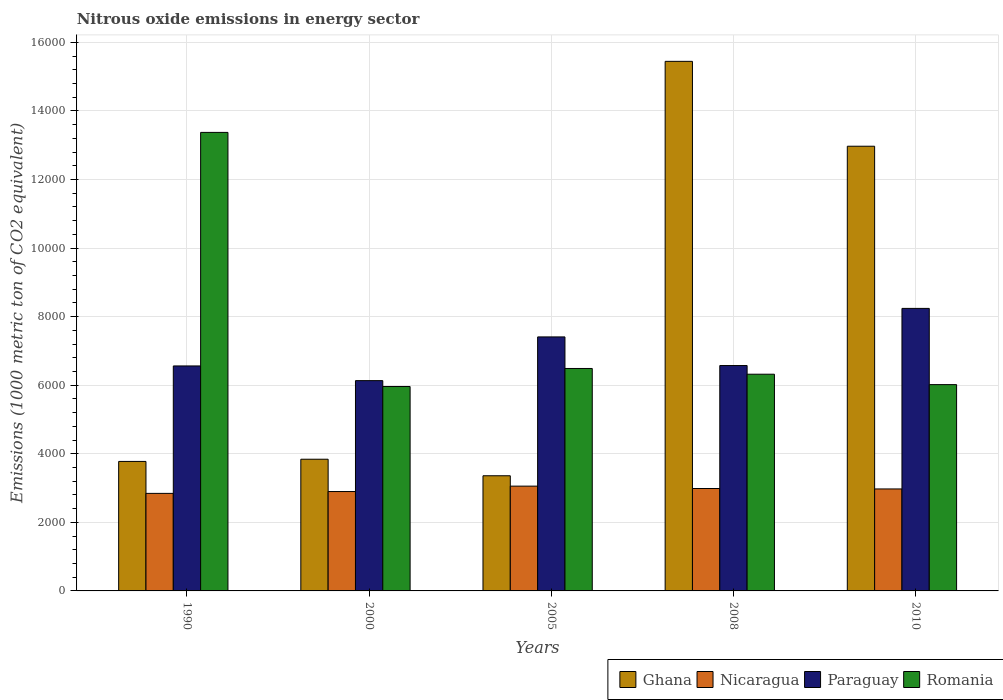How many different coloured bars are there?
Your answer should be very brief. 4. Are the number of bars per tick equal to the number of legend labels?
Your answer should be compact. Yes. Are the number of bars on each tick of the X-axis equal?
Make the answer very short. Yes. How many bars are there on the 1st tick from the left?
Make the answer very short. 4. In how many cases, is the number of bars for a given year not equal to the number of legend labels?
Offer a terse response. 0. What is the amount of nitrous oxide emitted in Nicaragua in 2010?
Give a very brief answer. 2973.9. Across all years, what is the maximum amount of nitrous oxide emitted in Paraguay?
Keep it short and to the point. 8239.6. Across all years, what is the minimum amount of nitrous oxide emitted in Romania?
Provide a succinct answer. 5961.2. In which year was the amount of nitrous oxide emitted in Paraguay maximum?
Keep it short and to the point. 2010. In which year was the amount of nitrous oxide emitted in Paraguay minimum?
Your response must be concise. 2000. What is the total amount of nitrous oxide emitted in Ghana in the graph?
Offer a terse response. 3.94e+04. What is the difference between the amount of nitrous oxide emitted in Romania in 1990 and that in 2010?
Your answer should be compact. 7355.9. What is the difference between the amount of nitrous oxide emitted in Ghana in 2005 and the amount of nitrous oxide emitted in Paraguay in 1990?
Make the answer very short. -3202.5. What is the average amount of nitrous oxide emitted in Ghana per year?
Your answer should be very brief. 7877.78. In the year 2000, what is the difference between the amount of nitrous oxide emitted in Nicaragua and amount of nitrous oxide emitted in Ghana?
Provide a succinct answer. -942.6. What is the ratio of the amount of nitrous oxide emitted in Nicaragua in 1990 to that in 2010?
Offer a very short reply. 0.96. Is the difference between the amount of nitrous oxide emitted in Nicaragua in 1990 and 2005 greater than the difference between the amount of nitrous oxide emitted in Ghana in 1990 and 2005?
Keep it short and to the point. No. What is the difference between the highest and the second highest amount of nitrous oxide emitted in Ghana?
Your response must be concise. 2475.2. What is the difference between the highest and the lowest amount of nitrous oxide emitted in Romania?
Offer a very short reply. 7411.1. In how many years, is the amount of nitrous oxide emitted in Paraguay greater than the average amount of nitrous oxide emitted in Paraguay taken over all years?
Offer a very short reply. 2. Is it the case that in every year, the sum of the amount of nitrous oxide emitted in Romania and amount of nitrous oxide emitted in Paraguay is greater than the sum of amount of nitrous oxide emitted in Nicaragua and amount of nitrous oxide emitted in Ghana?
Keep it short and to the point. Yes. What does the 3rd bar from the left in 2008 represents?
Ensure brevity in your answer.  Paraguay. What does the 2nd bar from the right in 2005 represents?
Offer a terse response. Paraguay. Is it the case that in every year, the sum of the amount of nitrous oxide emitted in Paraguay and amount of nitrous oxide emitted in Nicaragua is greater than the amount of nitrous oxide emitted in Romania?
Make the answer very short. No. How many bars are there?
Your answer should be compact. 20. Are all the bars in the graph horizontal?
Provide a short and direct response. No. Are the values on the major ticks of Y-axis written in scientific E-notation?
Give a very brief answer. No. Does the graph contain any zero values?
Ensure brevity in your answer.  No. Where does the legend appear in the graph?
Your answer should be very brief. Bottom right. What is the title of the graph?
Your answer should be compact. Nitrous oxide emissions in energy sector. What is the label or title of the Y-axis?
Your answer should be compact. Emissions (1000 metric ton of CO2 equivalent). What is the Emissions (1000 metric ton of CO2 equivalent) of Ghana in 1990?
Offer a terse response. 3776.4. What is the Emissions (1000 metric ton of CO2 equivalent) in Nicaragua in 1990?
Provide a short and direct response. 2844.7. What is the Emissions (1000 metric ton of CO2 equivalent) of Paraguay in 1990?
Offer a very short reply. 6561.2. What is the Emissions (1000 metric ton of CO2 equivalent) in Romania in 1990?
Give a very brief answer. 1.34e+04. What is the Emissions (1000 metric ton of CO2 equivalent) in Ghana in 2000?
Provide a short and direct response. 3840.8. What is the Emissions (1000 metric ton of CO2 equivalent) of Nicaragua in 2000?
Make the answer very short. 2898.2. What is the Emissions (1000 metric ton of CO2 equivalent) in Paraguay in 2000?
Your response must be concise. 6132.8. What is the Emissions (1000 metric ton of CO2 equivalent) of Romania in 2000?
Offer a very short reply. 5961.2. What is the Emissions (1000 metric ton of CO2 equivalent) of Ghana in 2005?
Make the answer very short. 3358.7. What is the Emissions (1000 metric ton of CO2 equivalent) of Nicaragua in 2005?
Your answer should be compact. 3056.1. What is the Emissions (1000 metric ton of CO2 equivalent) of Paraguay in 2005?
Provide a short and direct response. 7407.7. What is the Emissions (1000 metric ton of CO2 equivalent) of Romania in 2005?
Ensure brevity in your answer.  6487.3. What is the Emissions (1000 metric ton of CO2 equivalent) of Ghana in 2008?
Give a very brief answer. 1.54e+04. What is the Emissions (1000 metric ton of CO2 equivalent) in Nicaragua in 2008?
Keep it short and to the point. 2986.9. What is the Emissions (1000 metric ton of CO2 equivalent) of Paraguay in 2008?
Give a very brief answer. 6573. What is the Emissions (1000 metric ton of CO2 equivalent) in Romania in 2008?
Your answer should be very brief. 6320.1. What is the Emissions (1000 metric ton of CO2 equivalent) of Ghana in 2010?
Your answer should be compact. 1.30e+04. What is the Emissions (1000 metric ton of CO2 equivalent) in Nicaragua in 2010?
Offer a terse response. 2973.9. What is the Emissions (1000 metric ton of CO2 equivalent) of Paraguay in 2010?
Keep it short and to the point. 8239.6. What is the Emissions (1000 metric ton of CO2 equivalent) in Romania in 2010?
Give a very brief answer. 6016.4. Across all years, what is the maximum Emissions (1000 metric ton of CO2 equivalent) of Ghana?
Give a very brief answer. 1.54e+04. Across all years, what is the maximum Emissions (1000 metric ton of CO2 equivalent) in Nicaragua?
Offer a terse response. 3056.1. Across all years, what is the maximum Emissions (1000 metric ton of CO2 equivalent) of Paraguay?
Make the answer very short. 8239.6. Across all years, what is the maximum Emissions (1000 metric ton of CO2 equivalent) in Romania?
Keep it short and to the point. 1.34e+04. Across all years, what is the minimum Emissions (1000 metric ton of CO2 equivalent) in Ghana?
Give a very brief answer. 3358.7. Across all years, what is the minimum Emissions (1000 metric ton of CO2 equivalent) of Nicaragua?
Offer a terse response. 2844.7. Across all years, what is the minimum Emissions (1000 metric ton of CO2 equivalent) in Paraguay?
Your answer should be compact. 6132.8. Across all years, what is the minimum Emissions (1000 metric ton of CO2 equivalent) in Romania?
Offer a terse response. 5961.2. What is the total Emissions (1000 metric ton of CO2 equivalent) of Ghana in the graph?
Make the answer very short. 3.94e+04. What is the total Emissions (1000 metric ton of CO2 equivalent) of Nicaragua in the graph?
Offer a very short reply. 1.48e+04. What is the total Emissions (1000 metric ton of CO2 equivalent) in Paraguay in the graph?
Your answer should be compact. 3.49e+04. What is the total Emissions (1000 metric ton of CO2 equivalent) of Romania in the graph?
Your answer should be compact. 3.82e+04. What is the difference between the Emissions (1000 metric ton of CO2 equivalent) in Ghana in 1990 and that in 2000?
Make the answer very short. -64.4. What is the difference between the Emissions (1000 metric ton of CO2 equivalent) in Nicaragua in 1990 and that in 2000?
Make the answer very short. -53.5. What is the difference between the Emissions (1000 metric ton of CO2 equivalent) of Paraguay in 1990 and that in 2000?
Make the answer very short. 428.4. What is the difference between the Emissions (1000 metric ton of CO2 equivalent) in Romania in 1990 and that in 2000?
Give a very brief answer. 7411.1. What is the difference between the Emissions (1000 metric ton of CO2 equivalent) of Ghana in 1990 and that in 2005?
Ensure brevity in your answer.  417.7. What is the difference between the Emissions (1000 metric ton of CO2 equivalent) of Nicaragua in 1990 and that in 2005?
Your answer should be very brief. -211.4. What is the difference between the Emissions (1000 metric ton of CO2 equivalent) of Paraguay in 1990 and that in 2005?
Ensure brevity in your answer.  -846.5. What is the difference between the Emissions (1000 metric ton of CO2 equivalent) of Romania in 1990 and that in 2005?
Your response must be concise. 6885. What is the difference between the Emissions (1000 metric ton of CO2 equivalent) of Ghana in 1990 and that in 2008?
Your answer should be very brief. -1.17e+04. What is the difference between the Emissions (1000 metric ton of CO2 equivalent) in Nicaragua in 1990 and that in 2008?
Provide a short and direct response. -142.2. What is the difference between the Emissions (1000 metric ton of CO2 equivalent) in Romania in 1990 and that in 2008?
Keep it short and to the point. 7052.2. What is the difference between the Emissions (1000 metric ton of CO2 equivalent) of Ghana in 1990 and that in 2010?
Offer a very short reply. -9192.5. What is the difference between the Emissions (1000 metric ton of CO2 equivalent) of Nicaragua in 1990 and that in 2010?
Your answer should be compact. -129.2. What is the difference between the Emissions (1000 metric ton of CO2 equivalent) of Paraguay in 1990 and that in 2010?
Your answer should be compact. -1678.4. What is the difference between the Emissions (1000 metric ton of CO2 equivalent) in Romania in 1990 and that in 2010?
Your response must be concise. 7355.9. What is the difference between the Emissions (1000 metric ton of CO2 equivalent) in Ghana in 2000 and that in 2005?
Your answer should be compact. 482.1. What is the difference between the Emissions (1000 metric ton of CO2 equivalent) of Nicaragua in 2000 and that in 2005?
Keep it short and to the point. -157.9. What is the difference between the Emissions (1000 metric ton of CO2 equivalent) in Paraguay in 2000 and that in 2005?
Provide a short and direct response. -1274.9. What is the difference between the Emissions (1000 metric ton of CO2 equivalent) in Romania in 2000 and that in 2005?
Offer a terse response. -526.1. What is the difference between the Emissions (1000 metric ton of CO2 equivalent) in Ghana in 2000 and that in 2008?
Offer a very short reply. -1.16e+04. What is the difference between the Emissions (1000 metric ton of CO2 equivalent) in Nicaragua in 2000 and that in 2008?
Your answer should be very brief. -88.7. What is the difference between the Emissions (1000 metric ton of CO2 equivalent) of Paraguay in 2000 and that in 2008?
Offer a terse response. -440.2. What is the difference between the Emissions (1000 metric ton of CO2 equivalent) in Romania in 2000 and that in 2008?
Your answer should be compact. -358.9. What is the difference between the Emissions (1000 metric ton of CO2 equivalent) of Ghana in 2000 and that in 2010?
Your response must be concise. -9128.1. What is the difference between the Emissions (1000 metric ton of CO2 equivalent) in Nicaragua in 2000 and that in 2010?
Give a very brief answer. -75.7. What is the difference between the Emissions (1000 metric ton of CO2 equivalent) of Paraguay in 2000 and that in 2010?
Provide a short and direct response. -2106.8. What is the difference between the Emissions (1000 metric ton of CO2 equivalent) in Romania in 2000 and that in 2010?
Provide a short and direct response. -55.2. What is the difference between the Emissions (1000 metric ton of CO2 equivalent) of Ghana in 2005 and that in 2008?
Make the answer very short. -1.21e+04. What is the difference between the Emissions (1000 metric ton of CO2 equivalent) in Nicaragua in 2005 and that in 2008?
Provide a succinct answer. 69.2. What is the difference between the Emissions (1000 metric ton of CO2 equivalent) of Paraguay in 2005 and that in 2008?
Your answer should be compact. 834.7. What is the difference between the Emissions (1000 metric ton of CO2 equivalent) in Romania in 2005 and that in 2008?
Your answer should be compact. 167.2. What is the difference between the Emissions (1000 metric ton of CO2 equivalent) in Ghana in 2005 and that in 2010?
Offer a terse response. -9610.2. What is the difference between the Emissions (1000 metric ton of CO2 equivalent) in Nicaragua in 2005 and that in 2010?
Offer a terse response. 82.2. What is the difference between the Emissions (1000 metric ton of CO2 equivalent) in Paraguay in 2005 and that in 2010?
Ensure brevity in your answer.  -831.9. What is the difference between the Emissions (1000 metric ton of CO2 equivalent) of Romania in 2005 and that in 2010?
Provide a succinct answer. 470.9. What is the difference between the Emissions (1000 metric ton of CO2 equivalent) of Ghana in 2008 and that in 2010?
Keep it short and to the point. 2475.2. What is the difference between the Emissions (1000 metric ton of CO2 equivalent) of Paraguay in 2008 and that in 2010?
Give a very brief answer. -1666.6. What is the difference between the Emissions (1000 metric ton of CO2 equivalent) in Romania in 2008 and that in 2010?
Your answer should be very brief. 303.7. What is the difference between the Emissions (1000 metric ton of CO2 equivalent) of Ghana in 1990 and the Emissions (1000 metric ton of CO2 equivalent) of Nicaragua in 2000?
Offer a very short reply. 878.2. What is the difference between the Emissions (1000 metric ton of CO2 equivalent) of Ghana in 1990 and the Emissions (1000 metric ton of CO2 equivalent) of Paraguay in 2000?
Your answer should be very brief. -2356.4. What is the difference between the Emissions (1000 metric ton of CO2 equivalent) of Ghana in 1990 and the Emissions (1000 metric ton of CO2 equivalent) of Romania in 2000?
Make the answer very short. -2184.8. What is the difference between the Emissions (1000 metric ton of CO2 equivalent) in Nicaragua in 1990 and the Emissions (1000 metric ton of CO2 equivalent) in Paraguay in 2000?
Offer a very short reply. -3288.1. What is the difference between the Emissions (1000 metric ton of CO2 equivalent) in Nicaragua in 1990 and the Emissions (1000 metric ton of CO2 equivalent) in Romania in 2000?
Offer a very short reply. -3116.5. What is the difference between the Emissions (1000 metric ton of CO2 equivalent) of Paraguay in 1990 and the Emissions (1000 metric ton of CO2 equivalent) of Romania in 2000?
Give a very brief answer. 600. What is the difference between the Emissions (1000 metric ton of CO2 equivalent) of Ghana in 1990 and the Emissions (1000 metric ton of CO2 equivalent) of Nicaragua in 2005?
Your answer should be very brief. 720.3. What is the difference between the Emissions (1000 metric ton of CO2 equivalent) of Ghana in 1990 and the Emissions (1000 metric ton of CO2 equivalent) of Paraguay in 2005?
Offer a terse response. -3631.3. What is the difference between the Emissions (1000 metric ton of CO2 equivalent) in Ghana in 1990 and the Emissions (1000 metric ton of CO2 equivalent) in Romania in 2005?
Offer a terse response. -2710.9. What is the difference between the Emissions (1000 metric ton of CO2 equivalent) in Nicaragua in 1990 and the Emissions (1000 metric ton of CO2 equivalent) in Paraguay in 2005?
Your response must be concise. -4563. What is the difference between the Emissions (1000 metric ton of CO2 equivalent) of Nicaragua in 1990 and the Emissions (1000 metric ton of CO2 equivalent) of Romania in 2005?
Provide a succinct answer. -3642.6. What is the difference between the Emissions (1000 metric ton of CO2 equivalent) in Paraguay in 1990 and the Emissions (1000 metric ton of CO2 equivalent) in Romania in 2005?
Make the answer very short. 73.9. What is the difference between the Emissions (1000 metric ton of CO2 equivalent) of Ghana in 1990 and the Emissions (1000 metric ton of CO2 equivalent) of Nicaragua in 2008?
Offer a terse response. 789.5. What is the difference between the Emissions (1000 metric ton of CO2 equivalent) of Ghana in 1990 and the Emissions (1000 metric ton of CO2 equivalent) of Paraguay in 2008?
Your response must be concise. -2796.6. What is the difference between the Emissions (1000 metric ton of CO2 equivalent) in Ghana in 1990 and the Emissions (1000 metric ton of CO2 equivalent) in Romania in 2008?
Give a very brief answer. -2543.7. What is the difference between the Emissions (1000 metric ton of CO2 equivalent) in Nicaragua in 1990 and the Emissions (1000 metric ton of CO2 equivalent) in Paraguay in 2008?
Provide a succinct answer. -3728.3. What is the difference between the Emissions (1000 metric ton of CO2 equivalent) in Nicaragua in 1990 and the Emissions (1000 metric ton of CO2 equivalent) in Romania in 2008?
Offer a terse response. -3475.4. What is the difference between the Emissions (1000 metric ton of CO2 equivalent) in Paraguay in 1990 and the Emissions (1000 metric ton of CO2 equivalent) in Romania in 2008?
Make the answer very short. 241.1. What is the difference between the Emissions (1000 metric ton of CO2 equivalent) in Ghana in 1990 and the Emissions (1000 metric ton of CO2 equivalent) in Nicaragua in 2010?
Your response must be concise. 802.5. What is the difference between the Emissions (1000 metric ton of CO2 equivalent) in Ghana in 1990 and the Emissions (1000 metric ton of CO2 equivalent) in Paraguay in 2010?
Make the answer very short. -4463.2. What is the difference between the Emissions (1000 metric ton of CO2 equivalent) of Ghana in 1990 and the Emissions (1000 metric ton of CO2 equivalent) of Romania in 2010?
Your answer should be very brief. -2240. What is the difference between the Emissions (1000 metric ton of CO2 equivalent) in Nicaragua in 1990 and the Emissions (1000 metric ton of CO2 equivalent) in Paraguay in 2010?
Ensure brevity in your answer.  -5394.9. What is the difference between the Emissions (1000 metric ton of CO2 equivalent) in Nicaragua in 1990 and the Emissions (1000 metric ton of CO2 equivalent) in Romania in 2010?
Give a very brief answer. -3171.7. What is the difference between the Emissions (1000 metric ton of CO2 equivalent) of Paraguay in 1990 and the Emissions (1000 metric ton of CO2 equivalent) of Romania in 2010?
Offer a very short reply. 544.8. What is the difference between the Emissions (1000 metric ton of CO2 equivalent) of Ghana in 2000 and the Emissions (1000 metric ton of CO2 equivalent) of Nicaragua in 2005?
Ensure brevity in your answer.  784.7. What is the difference between the Emissions (1000 metric ton of CO2 equivalent) of Ghana in 2000 and the Emissions (1000 metric ton of CO2 equivalent) of Paraguay in 2005?
Provide a short and direct response. -3566.9. What is the difference between the Emissions (1000 metric ton of CO2 equivalent) of Ghana in 2000 and the Emissions (1000 metric ton of CO2 equivalent) of Romania in 2005?
Provide a short and direct response. -2646.5. What is the difference between the Emissions (1000 metric ton of CO2 equivalent) in Nicaragua in 2000 and the Emissions (1000 metric ton of CO2 equivalent) in Paraguay in 2005?
Provide a succinct answer. -4509.5. What is the difference between the Emissions (1000 metric ton of CO2 equivalent) of Nicaragua in 2000 and the Emissions (1000 metric ton of CO2 equivalent) of Romania in 2005?
Ensure brevity in your answer.  -3589.1. What is the difference between the Emissions (1000 metric ton of CO2 equivalent) of Paraguay in 2000 and the Emissions (1000 metric ton of CO2 equivalent) of Romania in 2005?
Provide a succinct answer. -354.5. What is the difference between the Emissions (1000 metric ton of CO2 equivalent) of Ghana in 2000 and the Emissions (1000 metric ton of CO2 equivalent) of Nicaragua in 2008?
Your answer should be very brief. 853.9. What is the difference between the Emissions (1000 metric ton of CO2 equivalent) in Ghana in 2000 and the Emissions (1000 metric ton of CO2 equivalent) in Paraguay in 2008?
Give a very brief answer. -2732.2. What is the difference between the Emissions (1000 metric ton of CO2 equivalent) of Ghana in 2000 and the Emissions (1000 metric ton of CO2 equivalent) of Romania in 2008?
Provide a succinct answer. -2479.3. What is the difference between the Emissions (1000 metric ton of CO2 equivalent) in Nicaragua in 2000 and the Emissions (1000 metric ton of CO2 equivalent) in Paraguay in 2008?
Your response must be concise. -3674.8. What is the difference between the Emissions (1000 metric ton of CO2 equivalent) of Nicaragua in 2000 and the Emissions (1000 metric ton of CO2 equivalent) of Romania in 2008?
Provide a succinct answer. -3421.9. What is the difference between the Emissions (1000 metric ton of CO2 equivalent) in Paraguay in 2000 and the Emissions (1000 metric ton of CO2 equivalent) in Romania in 2008?
Ensure brevity in your answer.  -187.3. What is the difference between the Emissions (1000 metric ton of CO2 equivalent) of Ghana in 2000 and the Emissions (1000 metric ton of CO2 equivalent) of Nicaragua in 2010?
Your answer should be very brief. 866.9. What is the difference between the Emissions (1000 metric ton of CO2 equivalent) of Ghana in 2000 and the Emissions (1000 metric ton of CO2 equivalent) of Paraguay in 2010?
Provide a short and direct response. -4398.8. What is the difference between the Emissions (1000 metric ton of CO2 equivalent) of Ghana in 2000 and the Emissions (1000 metric ton of CO2 equivalent) of Romania in 2010?
Offer a very short reply. -2175.6. What is the difference between the Emissions (1000 metric ton of CO2 equivalent) in Nicaragua in 2000 and the Emissions (1000 metric ton of CO2 equivalent) in Paraguay in 2010?
Make the answer very short. -5341.4. What is the difference between the Emissions (1000 metric ton of CO2 equivalent) of Nicaragua in 2000 and the Emissions (1000 metric ton of CO2 equivalent) of Romania in 2010?
Make the answer very short. -3118.2. What is the difference between the Emissions (1000 metric ton of CO2 equivalent) in Paraguay in 2000 and the Emissions (1000 metric ton of CO2 equivalent) in Romania in 2010?
Give a very brief answer. 116.4. What is the difference between the Emissions (1000 metric ton of CO2 equivalent) in Ghana in 2005 and the Emissions (1000 metric ton of CO2 equivalent) in Nicaragua in 2008?
Keep it short and to the point. 371.8. What is the difference between the Emissions (1000 metric ton of CO2 equivalent) of Ghana in 2005 and the Emissions (1000 metric ton of CO2 equivalent) of Paraguay in 2008?
Offer a terse response. -3214.3. What is the difference between the Emissions (1000 metric ton of CO2 equivalent) of Ghana in 2005 and the Emissions (1000 metric ton of CO2 equivalent) of Romania in 2008?
Your answer should be compact. -2961.4. What is the difference between the Emissions (1000 metric ton of CO2 equivalent) in Nicaragua in 2005 and the Emissions (1000 metric ton of CO2 equivalent) in Paraguay in 2008?
Provide a succinct answer. -3516.9. What is the difference between the Emissions (1000 metric ton of CO2 equivalent) in Nicaragua in 2005 and the Emissions (1000 metric ton of CO2 equivalent) in Romania in 2008?
Keep it short and to the point. -3264. What is the difference between the Emissions (1000 metric ton of CO2 equivalent) in Paraguay in 2005 and the Emissions (1000 metric ton of CO2 equivalent) in Romania in 2008?
Your answer should be compact. 1087.6. What is the difference between the Emissions (1000 metric ton of CO2 equivalent) in Ghana in 2005 and the Emissions (1000 metric ton of CO2 equivalent) in Nicaragua in 2010?
Provide a short and direct response. 384.8. What is the difference between the Emissions (1000 metric ton of CO2 equivalent) of Ghana in 2005 and the Emissions (1000 metric ton of CO2 equivalent) of Paraguay in 2010?
Make the answer very short. -4880.9. What is the difference between the Emissions (1000 metric ton of CO2 equivalent) in Ghana in 2005 and the Emissions (1000 metric ton of CO2 equivalent) in Romania in 2010?
Provide a succinct answer. -2657.7. What is the difference between the Emissions (1000 metric ton of CO2 equivalent) in Nicaragua in 2005 and the Emissions (1000 metric ton of CO2 equivalent) in Paraguay in 2010?
Provide a succinct answer. -5183.5. What is the difference between the Emissions (1000 metric ton of CO2 equivalent) of Nicaragua in 2005 and the Emissions (1000 metric ton of CO2 equivalent) of Romania in 2010?
Offer a very short reply. -2960.3. What is the difference between the Emissions (1000 metric ton of CO2 equivalent) of Paraguay in 2005 and the Emissions (1000 metric ton of CO2 equivalent) of Romania in 2010?
Your response must be concise. 1391.3. What is the difference between the Emissions (1000 metric ton of CO2 equivalent) of Ghana in 2008 and the Emissions (1000 metric ton of CO2 equivalent) of Nicaragua in 2010?
Provide a succinct answer. 1.25e+04. What is the difference between the Emissions (1000 metric ton of CO2 equivalent) in Ghana in 2008 and the Emissions (1000 metric ton of CO2 equivalent) in Paraguay in 2010?
Your response must be concise. 7204.5. What is the difference between the Emissions (1000 metric ton of CO2 equivalent) of Ghana in 2008 and the Emissions (1000 metric ton of CO2 equivalent) of Romania in 2010?
Your answer should be very brief. 9427.7. What is the difference between the Emissions (1000 metric ton of CO2 equivalent) in Nicaragua in 2008 and the Emissions (1000 metric ton of CO2 equivalent) in Paraguay in 2010?
Your response must be concise. -5252.7. What is the difference between the Emissions (1000 metric ton of CO2 equivalent) of Nicaragua in 2008 and the Emissions (1000 metric ton of CO2 equivalent) of Romania in 2010?
Give a very brief answer. -3029.5. What is the difference between the Emissions (1000 metric ton of CO2 equivalent) in Paraguay in 2008 and the Emissions (1000 metric ton of CO2 equivalent) in Romania in 2010?
Make the answer very short. 556.6. What is the average Emissions (1000 metric ton of CO2 equivalent) in Ghana per year?
Give a very brief answer. 7877.78. What is the average Emissions (1000 metric ton of CO2 equivalent) of Nicaragua per year?
Your answer should be compact. 2951.96. What is the average Emissions (1000 metric ton of CO2 equivalent) of Paraguay per year?
Provide a short and direct response. 6982.86. What is the average Emissions (1000 metric ton of CO2 equivalent) in Romania per year?
Make the answer very short. 7631.46. In the year 1990, what is the difference between the Emissions (1000 metric ton of CO2 equivalent) of Ghana and Emissions (1000 metric ton of CO2 equivalent) of Nicaragua?
Keep it short and to the point. 931.7. In the year 1990, what is the difference between the Emissions (1000 metric ton of CO2 equivalent) of Ghana and Emissions (1000 metric ton of CO2 equivalent) of Paraguay?
Make the answer very short. -2784.8. In the year 1990, what is the difference between the Emissions (1000 metric ton of CO2 equivalent) of Ghana and Emissions (1000 metric ton of CO2 equivalent) of Romania?
Make the answer very short. -9595.9. In the year 1990, what is the difference between the Emissions (1000 metric ton of CO2 equivalent) of Nicaragua and Emissions (1000 metric ton of CO2 equivalent) of Paraguay?
Offer a very short reply. -3716.5. In the year 1990, what is the difference between the Emissions (1000 metric ton of CO2 equivalent) in Nicaragua and Emissions (1000 metric ton of CO2 equivalent) in Romania?
Offer a terse response. -1.05e+04. In the year 1990, what is the difference between the Emissions (1000 metric ton of CO2 equivalent) of Paraguay and Emissions (1000 metric ton of CO2 equivalent) of Romania?
Your answer should be very brief. -6811.1. In the year 2000, what is the difference between the Emissions (1000 metric ton of CO2 equivalent) in Ghana and Emissions (1000 metric ton of CO2 equivalent) in Nicaragua?
Provide a short and direct response. 942.6. In the year 2000, what is the difference between the Emissions (1000 metric ton of CO2 equivalent) of Ghana and Emissions (1000 metric ton of CO2 equivalent) of Paraguay?
Give a very brief answer. -2292. In the year 2000, what is the difference between the Emissions (1000 metric ton of CO2 equivalent) in Ghana and Emissions (1000 metric ton of CO2 equivalent) in Romania?
Your answer should be compact. -2120.4. In the year 2000, what is the difference between the Emissions (1000 metric ton of CO2 equivalent) of Nicaragua and Emissions (1000 metric ton of CO2 equivalent) of Paraguay?
Provide a succinct answer. -3234.6. In the year 2000, what is the difference between the Emissions (1000 metric ton of CO2 equivalent) of Nicaragua and Emissions (1000 metric ton of CO2 equivalent) of Romania?
Ensure brevity in your answer.  -3063. In the year 2000, what is the difference between the Emissions (1000 metric ton of CO2 equivalent) in Paraguay and Emissions (1000 metric ton of CO2 equivalent) in Romania?
Your answer should be very brief. 171.6. In the year 2005, what is the difference between the Emissions (1000 metric ton of CO2 equivalent) of Ghana and Emissions (1000 metric ton of CO2 equivalent) of Nicaragua?
Give a very brief answer. 302.6. In the year 2005, what is the difference between the Emissions (1000 metric ton of CO2 equivalent) of Ghana and Emissions (1000 metric ton of CO2 equivalent) of Paraguay?
Provide a succinct answer. -4049. In the year 2005, what is the difference between the Emissions (1000 metric ton of CO2 equivalent) in Ghana and Emissions (1000 metric ton of CO2 equivalent) in Romania?
Give a very brief answer. -3128.6. In the year 2005, what is the difference between the Emissions (1000 metric ton of CO2 equivalent) of Nicaragua and Emissions (1000 metric ton of CO2 equivalent) of Paraguay?
Make the answer very short. -4351.6. In the year 2005, what is the difference between the Emissions (1000 metric ton of CO2 equivalent) of Nicaragua and Emissions (1000 metric ton of CO2 equivalent) of Romania?
Your answer should be compact. -3431.2. In the year 2005, what is the difference between the Emissions (1000 metric ton of CO2 equivalent) of Paraguay and Emissions (1000 metric ton of CO2 equivalent) of Romania?
Provide a short and direct response. 920.4. In the year 2008, what is the difference between the Emissions (1000 metric ton of CO2 equivalent) of Ghana and Emissions (1000 metric ton of CO2 equivalent) of Nicaragua?
Provide a succinct answer. 1.25e+04. In the year 2008, what is the difference between the Emissions (1000 metric ton of CO2 equivalent) of Ghana and Emissions (1000 metric ton of CO2 equivalent) of Paraguay?
Provide a short and direct response. 8871.1. In the year 2008, what is the difference between the Emissions (1000 metric ton of CO2 equivalent) of Ghana and Emissions (1000 metric ton of CO2 equivalent) of Romania?
Provide a succinct answer. 9124. In the year 2008, what is the difference between the Emissions (1000 metric ton of CO2 equivalent) of Nicaragua and Emissions (1000 metric ton of CO2 equivalent) of Paraguay?
Your answer should be compact. -3586.1. In the year 2008, what is the difference between the Emissions (1000 metric ton of CO2 equivalent) of Nicaragua and Emissions (1000 metric ton of CO2 equivalent) of Romania?
Give a very brief answer. -3333.2. In the year 2008, what is the difference between the Emissions (1000 metric ton of CO2 equivalent) in Paraguay and Emissions (1000 metric ton of CO2 equivalent) in Romania?
Provide a succinct answer. 252.9. In the year 2010, what is the difference between the Emissions (1000 metric ton of CO2 equivalent) in Ghana and Emissions (1000 metric ton of CO2 equivalent) in Nicaragua?
Ensure brevity in your answer.  9995. In the year 2010, what is the difference between the Emissions (1000 metric ton of CO2 equivalent) of Ghana and Emissions (1000 metric ton of CO2 equivalent) of Paraguay?
Offer a terse response. 4729.3. In the year 2010, what is the difference between the Emissions (1000 metric ton of CO2 equivalent) in Ghana and Emissions (1000 metric ton of CO2 equivalent) in Romania?
Offer a very short reply. 6952.5. In the year 2010, what is the difference between the Emissions (1000 metric ton of CO2 equivalent) of Nicaragua and Emissions (1000 metric ton of CO2 equivalent) of Paraguay?
Provide a succinct answer. -5265.7. In the year 2010, what is the difference between the Emissions (1000 metric ton of CO2 equivalent) in Nicaragua and Emissions (1000 metric ton of CO2 equivalent) in Romania?
Your answer should be very brief. -3042.5. In the year 2010, what is the difference between the Emissions (1000 metric ton of CO2 equivalent) of Paraguay and Emissions (1000 metric ton of CO2 equivalent) of Romania?
Ensure brevity in your answer.  2223.2. What is the ratio of the Emissions (1000 metric ton of CO2 equivalent) of Ghana in 1990 to that in 2000?
Provide a short and direct response. 0.98. What is the ratio of the Emissions (1000 metric ton of CO2 equivalent) in Nicaragua in 1990 to that in 2000?
Offer a terse response. 0.98. What is the ratio of the Emissions (1000 metric ton of CO2 equivalent) of Paraguay in 1990 to that in 2000?
Provide a short and direct response. 1.07. What is the ratio of the Emissions (1000 metric ton of CO2 equivalent) in Romania in 1990 to that in 2000?
Your answer should be compact. 2.24. What is the ratio of the Emissions (1000 metric ton of CO2 equivalent) of Ghana in 1990 to that in 2005?
Give a very brief answer. 1.12. What is the ratio of the Emissions (1000 metric ton of CO2 equivalent) of Nicaragua in 1990 to that in 2005?
Your answer should be very brief. 0.93. What is the ratio of the Emissions (1000 metric ton of CO2 equivalent) of Paraguay in 1990 to that in 2005?
Your response must be concise. 0.89. What is the ratio of the Emissions (1000 metric ton of CO2 equivalent) of Romania in 1990 to that in 2005?
Offer a very short reply. 2.06. What is the ratio of the Emissions (1000 metric ton of CO2 equivalent) of Ghana in 1990 to that in 2008?
Ensure brevity in your answer.  0.24. What is the ratio of the Emissions (1000 metric ton of CO2 equivalent) of Nicaragua in 1990 to that in 2008?
Provide a succinct answer. 0.95. What is the ratio of the Emissions (1000 metric ton of CO2 equivalent) of Paraguay in 1990 to that in 2008?
Ensure brevity in your answer.  1. What is the ratio of the Emissions (1000 metric ton of CO2 equivalent) in Romania in 1990 to that in 2008?
Your answer should be very brief. 2.12. What is the ratio of the Emissions (1000 metric ton of CO2 equivalent) in Ghana in 1990 to that in 2010?
Your response must be concise. 0.29. What is the ratio of the Emissions (1000 metric ton of CO2 equivalent) in Nicaragua in 1990 to that in 2010?
Your answer should be compact. 0.96. What is the ratio of the Emissions (1000 metric ton of CO2 equivalent) in Paraguay in 1990 to that in 2010?
Provide a short and direct response. 0.8. What is the ratio of the Emissions (1000 metric ton of CO2 equivalent) in Romania in 1990 to that in 2010?
Ensure brevity in your answer.  2.22. What is the ratio of the Emissions (1000 metric ton of CO2 equivalent) of Ghana in 2000 to that in 2005?
Keep it short and to the point. 1.14. What is the ratio of the Emissions (1000 metric ton of CO2 equivalent) in Nicaragua in 2000 to that in 2005?
Offer a very short reply. 0.95. What is the ratio of the Emissions (1000 metric ton of CO2 equivalent) in Paraguay in 2000 to that in 2005?
Your response must be concise. 0.83. What is the ratio of the Emissions (1000 metric ton of CO2 equivalent) of Romania in 2000 to that in 2005?
Give a very brief answer. 0.92. What is the ratio of the Emissions (1000 metric ton of CO2 equivalent) of Ghana in 2000 to that in 2008?
Offer a terse response. 0.25. What is the ratio of the Emissions (1000 metric ton of CO2 equivalent) in Nicaragua in 2000 to that in 2008?
Make the answer very short. 0.97. What is the ratio of the Emissions (1000 metric ton of CO2 equivalent) of Paraguay in 2000 to that in 2008?
Give a very brief answer. 0.93. What is the ratio of the Emissions (1000 metric ton of CO2 equivalent) in Romania in 2000 to that in 2008?
Offer a terse response. 0.94. What is the ratio of the Emissions (1000 metric ton of CO2 equivalent) in Ghana in 2000 to that in 2010?
Offer a terse response. 0.3. What is the ratio of the Emissions (1000 metric ton of CO2 equivalent) of Nicaragua in 2000 to that in 2010?
Your answer should be compact. 0.97. What is the ratio of the Emissions (1000 metric ton of CO2 equivalent) in Paraguay in 2000 to that in 2010?
Give a very brief answer. 0.74. What is the ratio of the Emissions (1000 metric ton of CO2 equivalent) of Romania in 2000 to that in 2010?
Make the answer very short. 0.99. What is the ratio of the Emissions (1000 metric ton of CO2 equivalent) of Ghana in 2005 to that in 2008?
Make the answer very short. 0.22. What is the ratio of the Emissions (1000 metric ton of CO2 equivalent) in Nicaragua in 2005 to that in 2008?
Provide a short and direct response. 1.02. What is the ratio of the Emissions (1000 metric ton of CO2 equivalent) of Paraguay in 2005 to that in 2008?
Give a very brief answer. 1.13. What is the ratio of the Emissions (1000 metric ton of CO2 equivalent) of Romania in 2005 to that in 2008?
Give a very brief answer. 1.03. What is the ratio of the Emissions (1000 metric ton of CO2 equivalent) of Ghana in 2005 to that in 2010?
Offer a terse response. 0.26. What is the ratio of the Emissions (1000 metric ton of CO2 equivalent) in Nicaragua in 2005 to that in 2010?
Your answer should be very brief. 1.03. What is the ratio of the Emissions (1000 metric ton of CO2 equivalent) in Paraguay in 2005 to that in 2010?
Offer a very short reply. 0.9. What is the ratio of the Emissions (1000 metric ton of CO2 equivalent) in Romania in 2005 to that in 2010?
Your answer should be compact. 1.08. What is the ratio of the Emissions (1000 metric ton of CO2 equivalent) of Ghana in 2008 to that in 2010?
Offer a terse response. 1.19. What is the ratio of the Emissions (1000 metric ton of CO2 equivalent) in Nicaragua in 2008 to that in 2010?
Provide a short and direct response. 1. What is the ratio of the Emissions (1000 metric ton of CO2 equivalent) of Paraguay in 2008 to that in 2010?
Give a very brief answer. 0.8. What is the ratio of the Emissions (1000 metric ton of CO2 equivalent) in Romania in 2008 to that in 2010?
Make the answer very short. 1.05. What is the difference between the highest and the second highest Emissions (1000 metric ton of CO2 equivalent) of Ghana?
Offer a very short reply. 2475.2. What is the difference between the highest and the second highest Emissions (1000 metric ton of CO2 equivalent) of Nicaragua?
Provide a short and direct response. 69.2. What is the difference between the highest and the second highest Emissions (1000 metric ton of CO2 equivalent) of Paraguay?
Your response must be concise. 831.9. What is the difference between the highest and the second highest Emissions (1000 metric ton of CO2 equivalent) in Romania?
Give a very brief answer. 6885. What is the difference between the highest and the lowest Emissions (1000 metric ton of CO2 equivalent) of Ghana?
Your answer should be compact. 1.21e+04. What is the difference between the highest and the lowest Emissions (1000 metric ton of CO2 equivalent) of Nicaragua?
Offer a very short reply. 211.4. What is the difference between the highest and the lowest Emissions (1000 metric ton of CO2 equivalent) of Paraguay?
Give a very brief answer. 2106.8. What is the difference between the highest and the lowest Emissions (1000 metric ton of CO2 equivalent) in Romania?
Keep it short and to the point. 7411.1. 